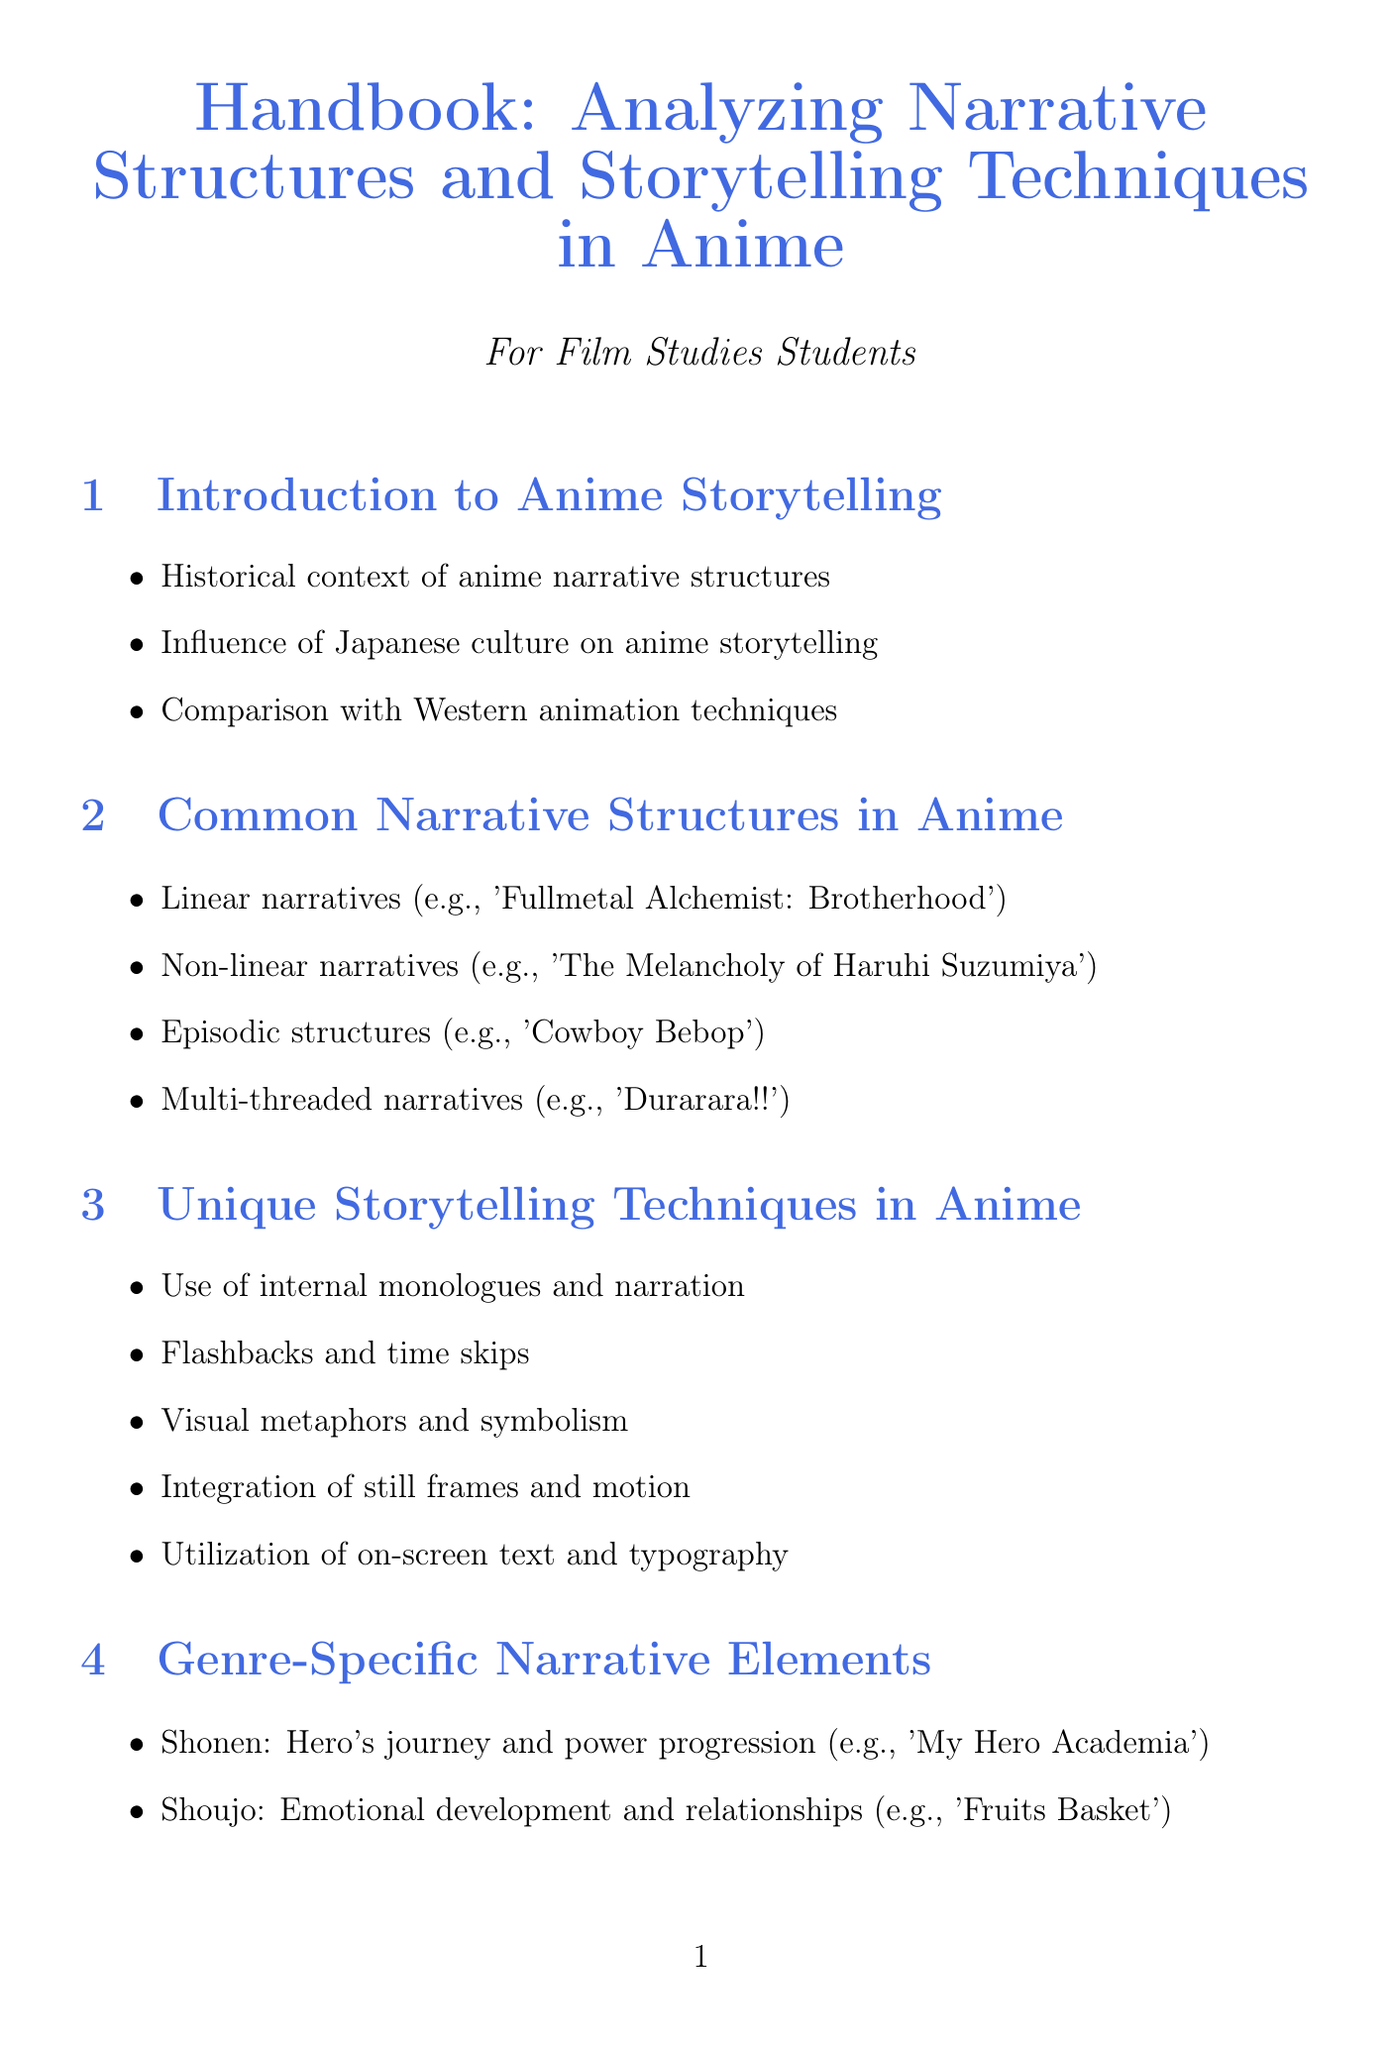What is the title of the handbook? The title of the handbook is stated at the beginning of the document as "Handbook: Analyzing Narrative Structures and Storytelling Techniques in Anime."
Answer: Handbook: Analyzing Narrative Structures and Storytelling Techniques in Anime How many sections are in the handbook? The document outlines ten main sections that cover various aspects of anime storytelling.
Answer: Ten Which anime is an example of a linear narrative? The handbook provides "Fullmetal Alchemist: Brotherhood" as a specific example of a linear narrative structure.
Answer: Fullmetal Alchemist: Brotherhood What storytelling technique involves internal thoughts? The handbook describes "Use of internal monologues and narration" as a unique storytelling technique in anime.
Answer: Use of internal monologues and narration What genre focuses on emotional development and relationships? The handbook identifies "Shoujo" as the genre that emphasizes emotional development and relationships.
Answer: Shoujo Who is the focus concerning Studio Ghibli's narrative techniques? The handbook specifies that the focus concerning Studio Ghibli's narrative techniques is on Hayao Miyazaki's works.
Answer: Hayao Miyazaki What color is associated with the document's theme? The document contains a specific color code defined as "animeblue," which is used throughout the title and headings.
Answer: animeblue How does the handbook categorize anime narrative approaches? The handbook categorizes anime narrative approaches into various sections such as common structures, unique techniques, and genre-specific elements.
Answer: Various sections What is the content of the appendices? The appendices consist of a glossary, a timeline of influential works, and a recommended viewing list relevant to anime narrative analysis.
Answer: Glossary, Timeline, Recommended Viewing List 